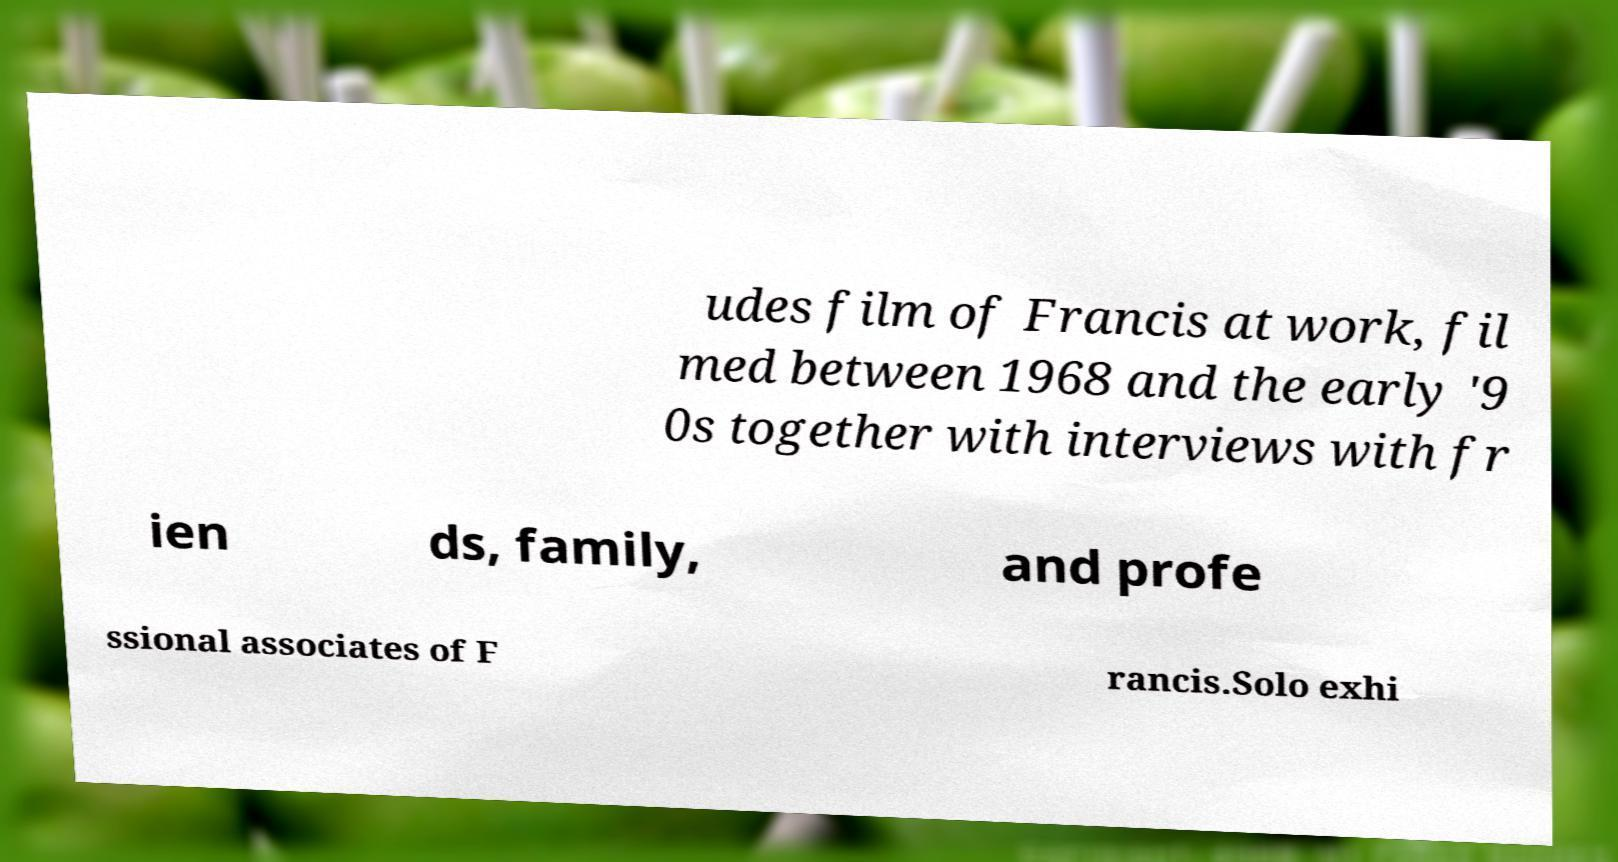For documentation purposes, I need the text within this image transcribed. Could you provide that? udes film of Francis at work, fil med between 1968 and the early '9 0s together with interviews with fr ien ds, family, and profe ssional associates of F rancis.Solo exhi 